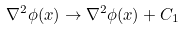Convert formula to latex. <formula><loc_0><loc_0><loc_500><loc_500>\nabla ^ { 2 } \phi ( x ) \rightarrow \nabla ^ { 2 } \phi ( x ) + C _ { 1 }</formula> 